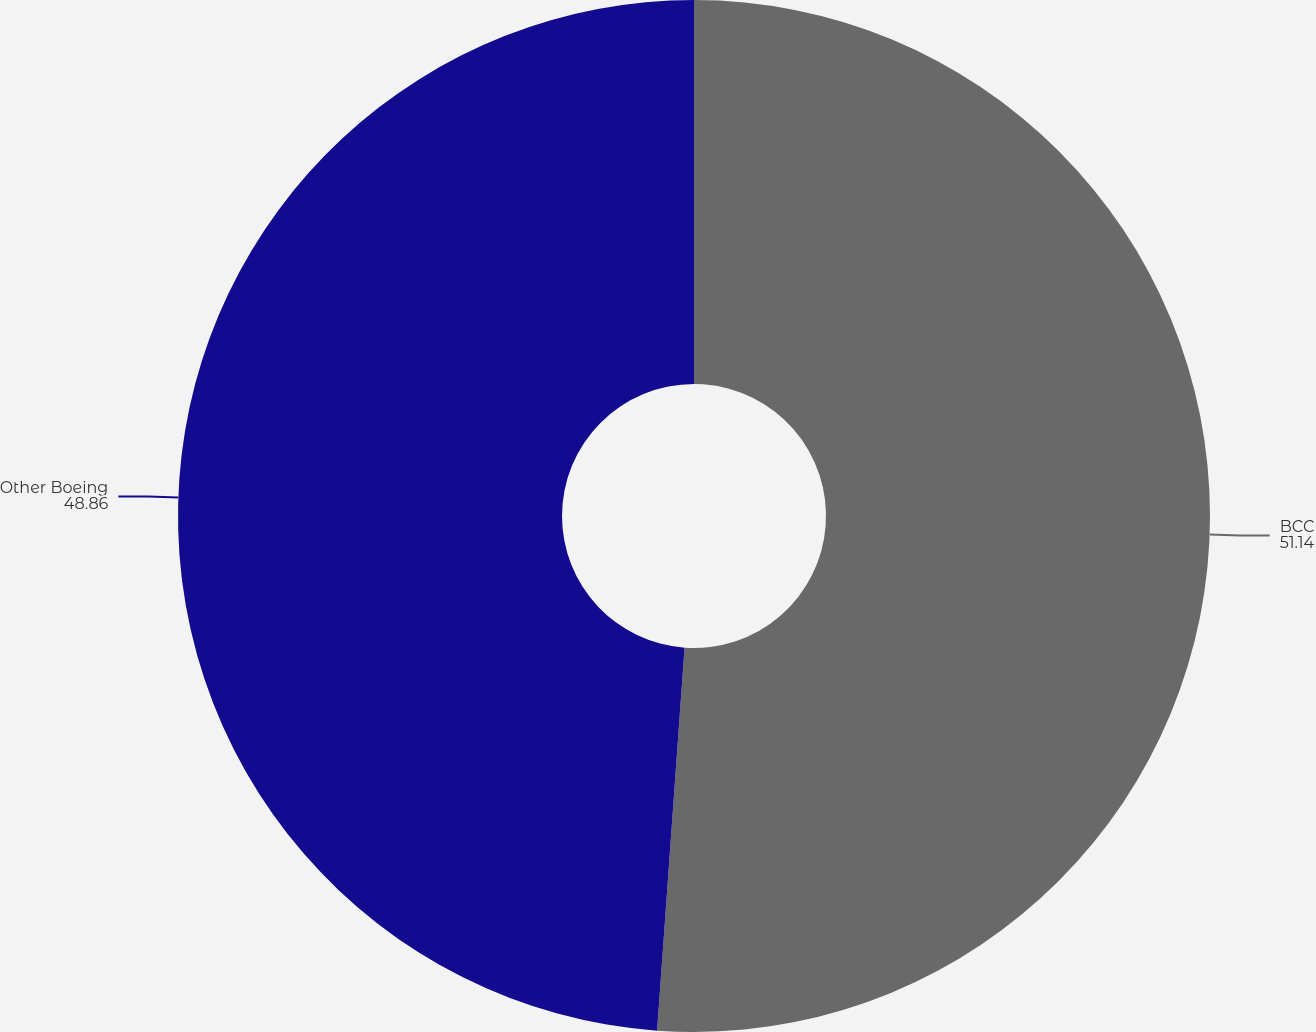Convert chart. <chart><loc_0><loc_0><loc_500><loc_500><pie_chart><fcel>BCC<fcel>Other Boeing<nl><fcel>51.14%<fcel>48.86%<nl></chart> 